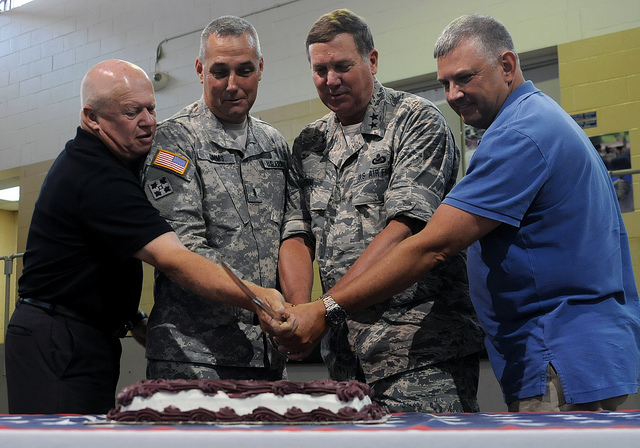How many candles are there? In the image, there are actually no candles on the cake that the individuals are surrounding. 